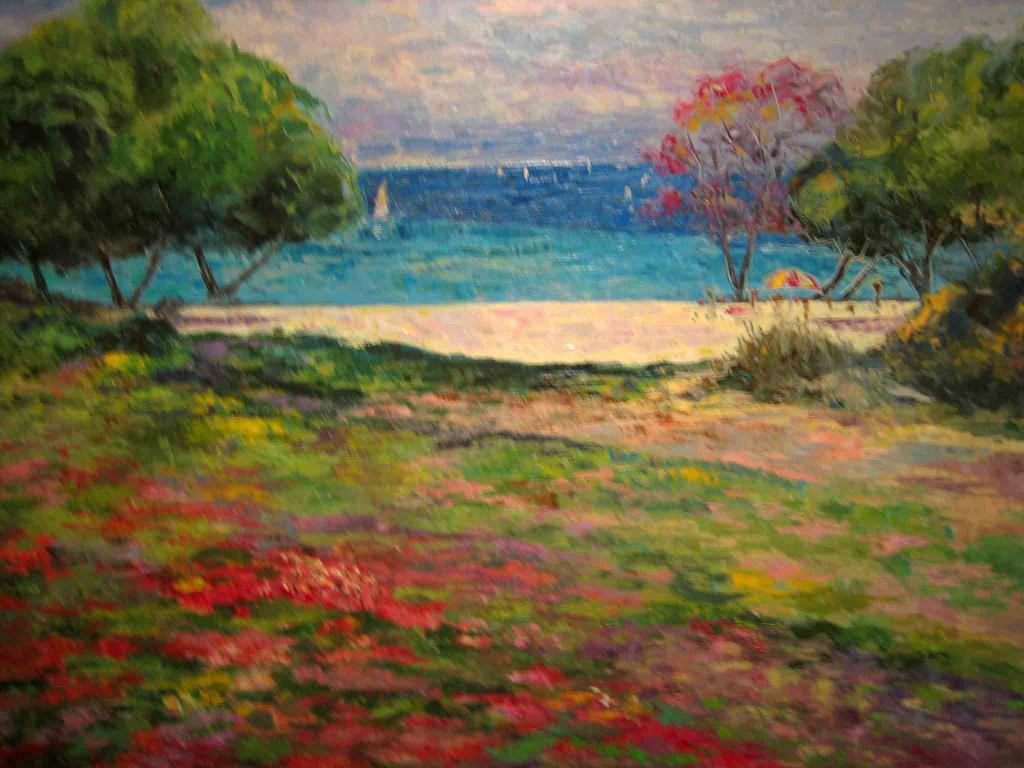What type of artwork is depicted in the image? The image appears to be a painting. What natural elements can be seen in the painting? There are trees and water in the image. How would you describe the sky in the painting? The sky in the image is blue and cloudy. Where is the key hidden in the painting? There is no key present in the painting; it is a landscape featuring trees, water, and a blue, cloudy sky. 